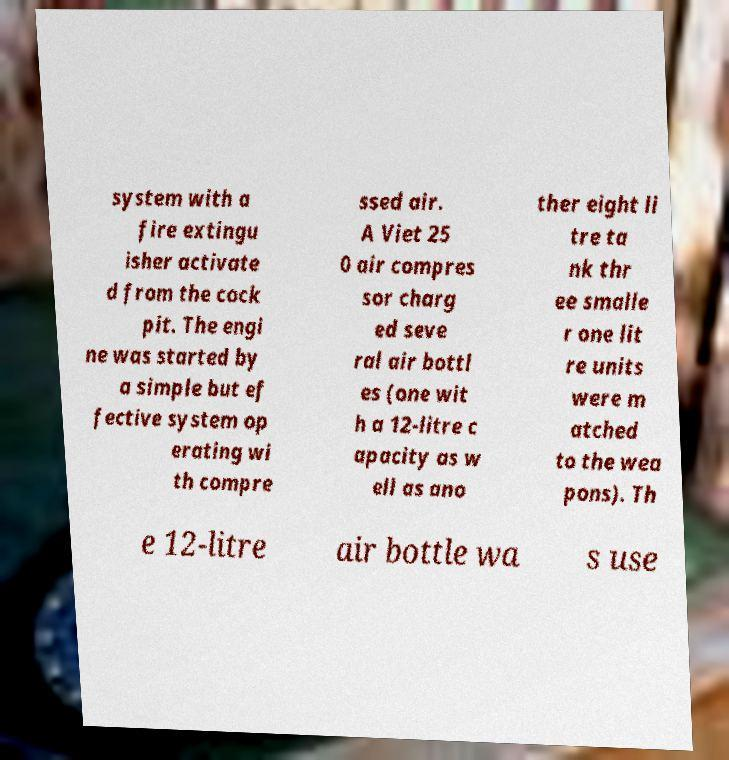There's text embedded in this image that I need extracted. Can you transcribe it verbatim? system with a fire extingu isher activate d from the cock pit. The engi ne was started by a simple but ef fective system op erating wi th compre ssed air. A Viet 25 0 air compres sor charg ed seve ral air bottl es (one wit h a 12-litre c apacity as w ell as ano ther eight li tre ta nk thr ee smalle r one lit re units were m atched to the wea pons). Th e 12-litre air bottle wa s use 